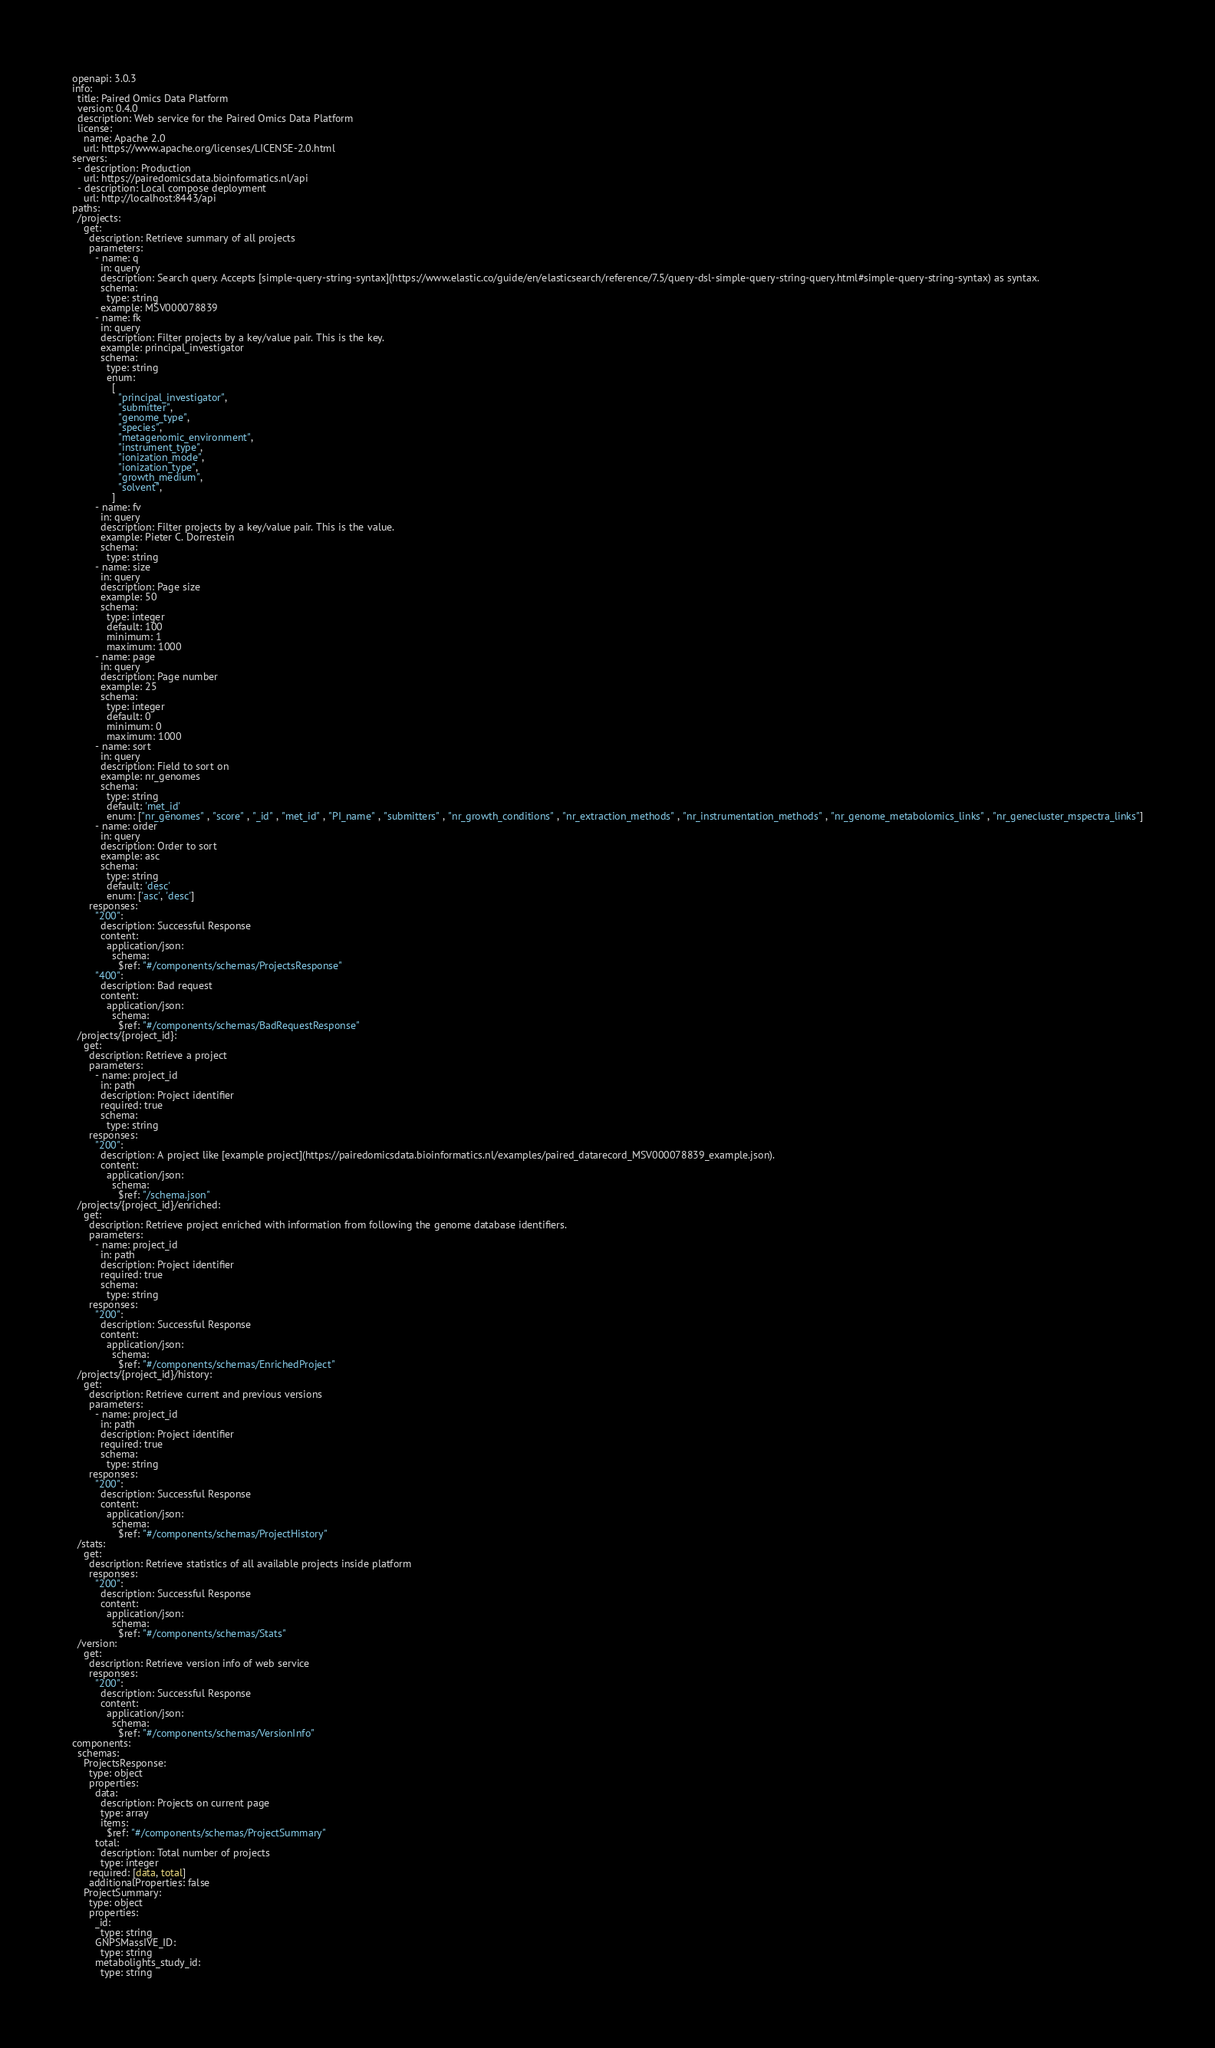<code> <loc_0><loc_0><loc_500><loc_500><_YAML_>openapi: 3.0.3
info:
  title: Paired Omics Data Platform
  version: 0.4.0
  description: Web service for the Paired Omics Data Platform
  license:
    name: Apache 2.0
    url: https://www.apache.org/licenses/LICENSE-2.0.html
servers:
  - description: Production
    url: https://pairedomicsdata.bioinformatics.nl/api
  - description: Local compose deployment
    url: http://localhost:8443/api
paths:
  /projects:
    get:
      description: Retrieve summary of all projects
      parameters:
        - name: q
          in: query
          description: Search query. Accepts [simple-query-string-syntax](https://www.elastic.co/guide/en/elasticsearch/reference/7.5/query-dsl-simple-query-string-query.html#simple-query-string-syntax) as syntax.
          schema:
            type: string
          example: MSV000078839
        - name: fk
          in: query
          description: Filter projects by a key/value pair. This is the key.
          example: principal_investigator
          schema:
            type: string
            enum:
              [
                "principal_investigator",
                "submitter",
                "genome_type",
                "species",
                "metagenomic_environment",
                "instrument_type",
                "ionization_mode",
                "ionization_type",
                "growth_medium",
                "solvent",
              ]
        - name: fv
          in: query
          description: Filter projects by a key/value pair. This is the value.
          example: Pieter C. Dorrestein
          schema:
            type: string
        - name: size
          in: query
          description: Page size
          example: 50
          schema:
            type: integer
            default: 100
            minimum: 1
            maximum: 1000
        - name: page
          in: query
          description: Page number
          example: 25
          schema:
            type: integer
            default: 0
            minimum: 0
            maximum: 1000
        - name: sort
          in: query
          description: Field to sort on
          example: nr_genomes
          schema:
            type: string
            default: 'met_id'
            enum: ["nr_genomes" , "score" , "_id" , "met_id" , "PI_name" , "submitters" , "nr_growth_conditions" , "nr_extraction_methods" , "nr_instrumentation_methods" , "nr_genome_metabolomics_links" , "nr_genecluster_mspectra_links"]
        - name: order
          in: query
          description: Order to sort
          example: asc
          schema:
            type: string
            default: 'desc'
            enum: ['asc', 'desc']
      responses:
        "200":
          description: Successful Response
          content:
            application/json:
              schema:
                $ref: "#/components/schemas/ProjectsResponse"
        "400":
          description: Bad request
          content:
            application/json:
              schema:
                $ref: "#/components/schemas/BadRequestResponse"
  /projects/{project_id}:
    get:
      description: Retrieve a project
      parameters:
        - name: project_id
          in: path
          description: Project identifier
          required: true
          schema:
            type: string
      responses:
        "200":
          description: A project like [example project](https://pairedomicsdata.bioinformatics.nl/examples/paired_datarecord_MSV000078839_example.json).
          content:
            application/json:
              schema:
                $ref: "/schema.json"
  /projects/{project_id}/enriched:
    get:
      description: Retrieve project enriched with information from following the genome database identifiers.
      parameters:
        - name: project_id
          in: path
          description: Project identifier
          required: true
          schema:
            type: string
      responses:
        "200":
          description: Successful Response
          content:
            application/json:
              schema:
                $ref: "#/components/schemas/EnrichedProject"
  /projects/{project_id}/history:
    get:
      description: Retrieve current and previous versions
      parameters:
        - name: project_id
          in: path
          description: Project identifier
          required: true
          schema:
            type: string
      responses:
        "200":
          description: Successful Response
          content:
            application/json:
              schema:
                $ref: "#/components/schemas/ProjectHistory"
  /stats:
    get:
      description: Retrieve statistics of all available projects inside platform
      responses:
        "200":
          description: Successful Response
          content:
            application/json:
              schema:
                $ref: "#/components/schemas/Stats"
  /version:
    get:
      description: Retrieve version info of web service
      responses:
        "200":
          description: Successful Response
          content:
            application/json:
              schema:
                $ref: "#/components/schemas/VersionInfo"
components:
  schemas:
    ProjectsResponse:
      type: object
      properties:
        data:
          description: Projects on current page
          type: array
          items:
            $ref: "#/components/schemas/ProjectSummary"
        total:
          description: Total number of projects
          type: integer
      required: [data, total]
      additionalProperties: false
    ProjectSummary:
      type: object
      properties:
        _id:
          type: string
        GNPSMassIVE_ID:
          type: string
        metabolights_study_id:
          type: string</code> 